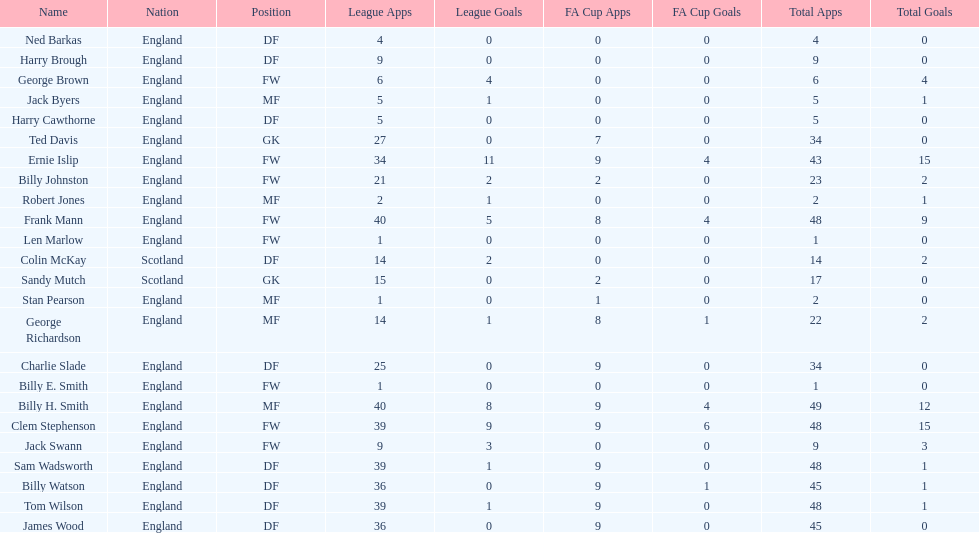What are the number of league apps ted davis has? 27. Help me parse the entirety of this table. {'header': ['Name', 'Nation', 'Position', 'League Apps', 'League Goals', 'FA Cup Apps', 'FA Cup Goals', 'Total Apps', 'Total Goals'], 'rows': [['Ned Barkas', 'England', 'DF', '4', '0', '0', '0', '4', '0'], ['Harry Brough', 'England', 'DF', '9', '0', '0', '0', '9', '0'], ['George Brown', 'England', 'FW', '6', '4', '0', '0', '6', '4'], ['Jack Byers', 'England', 'MF', '5', '1', '0', '0', '5', '1'], ['Harry Cawthorne', 'England', 'DF', '5', '0', '0', '0', '5', '0'], ['Ted Davis', 'England', 'GK', '27', '0', '7', '0', '34', '0'], ['Ernie Islip', 'England', 'FW', '34', '11', '9', '4', '43', '15'], ['Billy Johnston', 'England', 'FW', '21', '2', '2', '0', '23', '2'], ['Robert Jones', 'England', 'MF', '2', '1', '0', '0', '2', '1'], ['Frank Mann', 'England', 'FW', '40', '5', '8', '4', '48', '9'], ['Len Marlow', 'England', 'FW', '1', '0', '0', '0', '1', '0'], ['Colin McKay', 'Scotland', 'DF', '14', '2', '0', '0', '14', '2'], ['Sandy Mutch', 'Scotland', 'GK', '15', '0', '2', '0', '17', '0'], ['Stan Pearson', 'England', 'MF', '1', '0', '1', '0', '2', '0'], ['George Richardson', 'England', 'MF', '14', '1', '8', '1', '22', '2'], ['Charlie Slade', 'England', 'DF', '25', '0', '9', '0', '34', '0'], ['Billy E. Smith', 'England', 'FW', '1', '0', '0', '0', '1', '0'], ['Billy H. Smith', 'England', 'MF', '40', '8', '9', '4', '49', '12'], ['Clem Stephenson', 'England', 'FW', '39', '9', '9', '6', '48', '15'], ['Jack Swann', 'England', 'FW', '9', '3', '0', '0', '9', '3'], ['Sam Wadsworth', 'England', 'DF', '39', '1', '9', '0', '48', '1'], ['Billy Watson', 'England', 'DF', '36', '0', '9', '1', '45', '1'], ['Tom Wilson', 'England', 'DF', '39', '1', '9', '0', '48', '1'], ['James Wood', 'England', 'DF', '36', '0', '9', '0', '45', '0']]} 